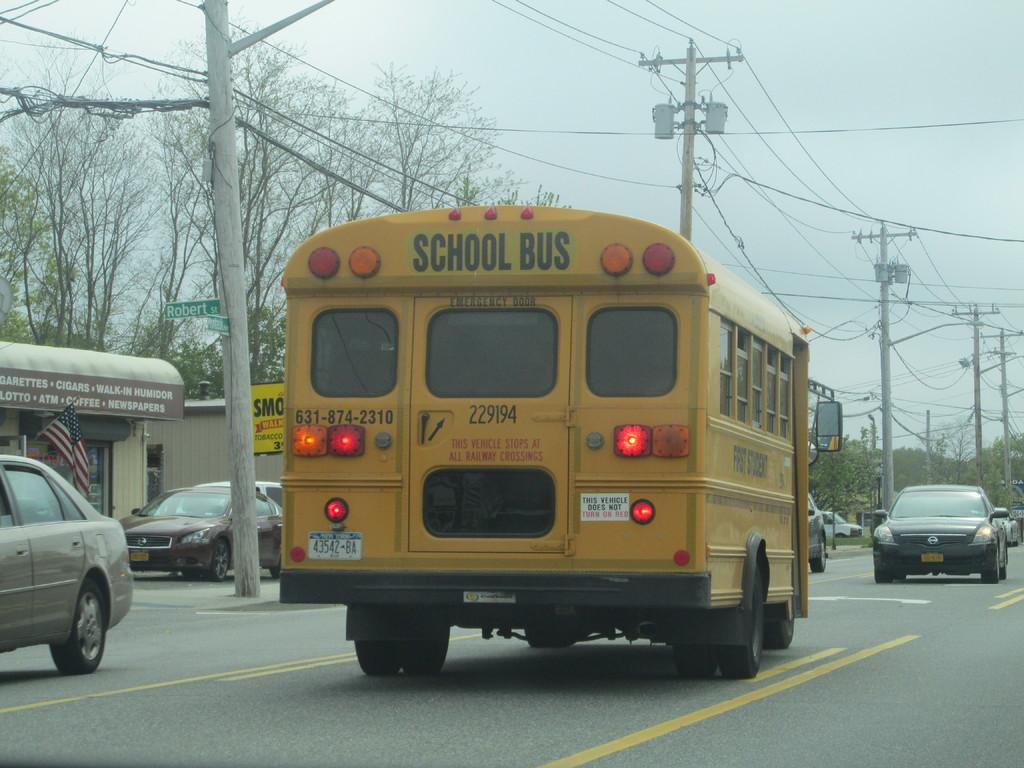What type of vehicles can be seen on the road in the image? There are motor vehicles on the road in the image. What structures are present alongside the road? Electric poles are present in the image. What is connected to the electric poles? Electric cables are visible in the image. What is the symbolic object in the image? There is a flag in the image. What type of signage is present in the image? Information boards are present in the image. What type of natural elements can be seen in the image? Trees are visible in the image. What part of the natural environment is visible in the image? The sky is visible in the image. What atmospheric elements can be seen in the sky? Clouds are present in the sky. What type of ink can be seen dripping from the trees in the image? There is no ink present in the image; it is a natural scene with trees and no indication of ink or any ink-related activity. 